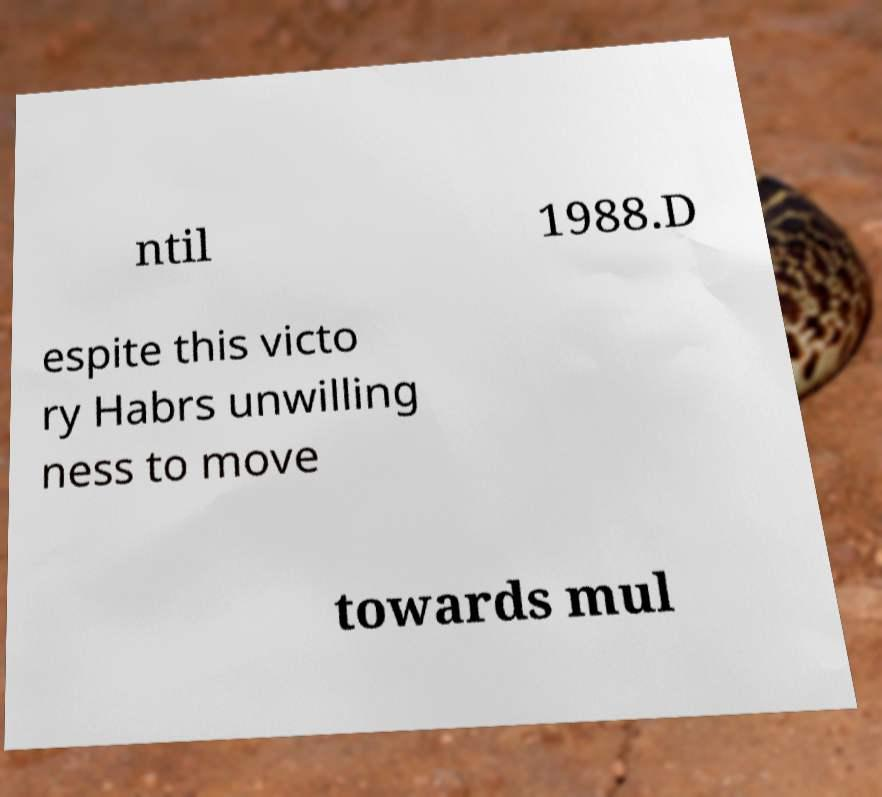What messages or text are displayed in this image? I need them in a readable, typed format. ntil 1988.D espite this victo ry Habrs unwilling ness to move towards mul 